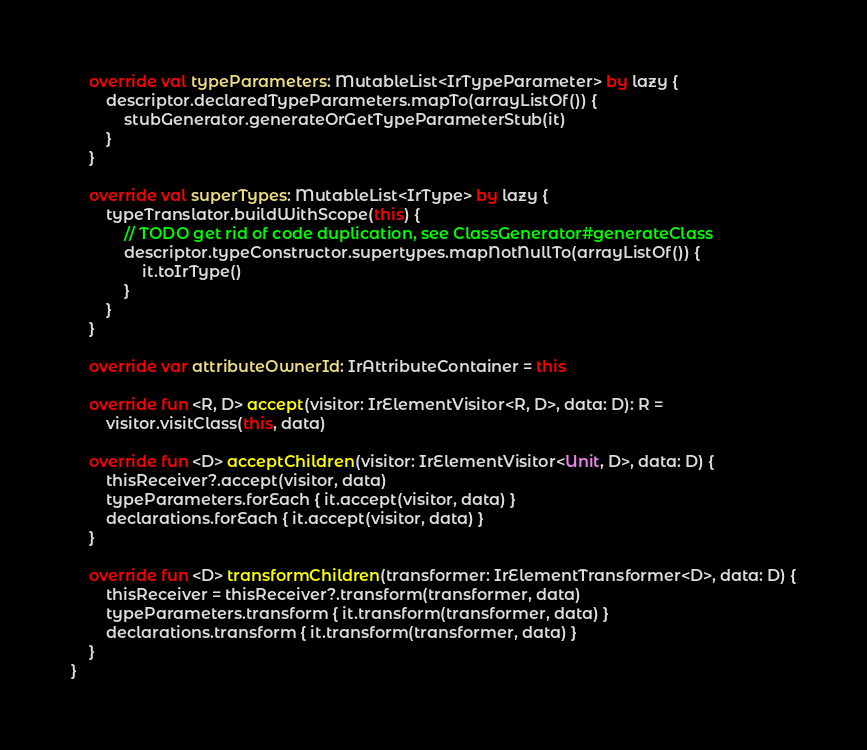<code> <loc_0><loc_0><loc_500><loc_500><_Kotlin_>    override val typeParameters: MutableList<IrTypeParameter> by lazy {
        descriptor.declaredTypeParameters.mapTo(arrayListOf()) {
            stubGenerator.generateOrGetTypeParameterStub(it)
        }
    }

    override val superTypes: MutableList<IrType> by lazy {
        typeTranslator.buildWithScope(this) {
            // TODO get rid of code duplication, see ClassGenerator#generateClass
            descriptor.typeConstructor.supertypes.mapNotNullTo(arrayListOf()) {
                it.toIrType()
            }
        }
    }

    override var attributeOwnerId: IrAttributeContainer = this

    override fun <R, D> accept(visitor: IrElementVisitor<R, D>, data: D): R =
        visitor.visitClass(this, data)

    override fun <D> acceptChildren(visitor: IrElementVisitor<Unit, D>, data: D) {
        thisReceiver?.accept(visitor, data)
        typeParameters.forEach { it.accept(visitor, data) }
        declarations.forEach { it.accept(visitor, data) }
    }

    override fun <D> transformChildren(transformer: IrElementTransformer<D>, data: D) {
        thisReceiver = thisReceiver?.transform(transformer, data)
        typeParameters.transform { it.transform(transformer, data) }
        declarations.transform { it.transform(transformer, data) }
    }
}
</code> 